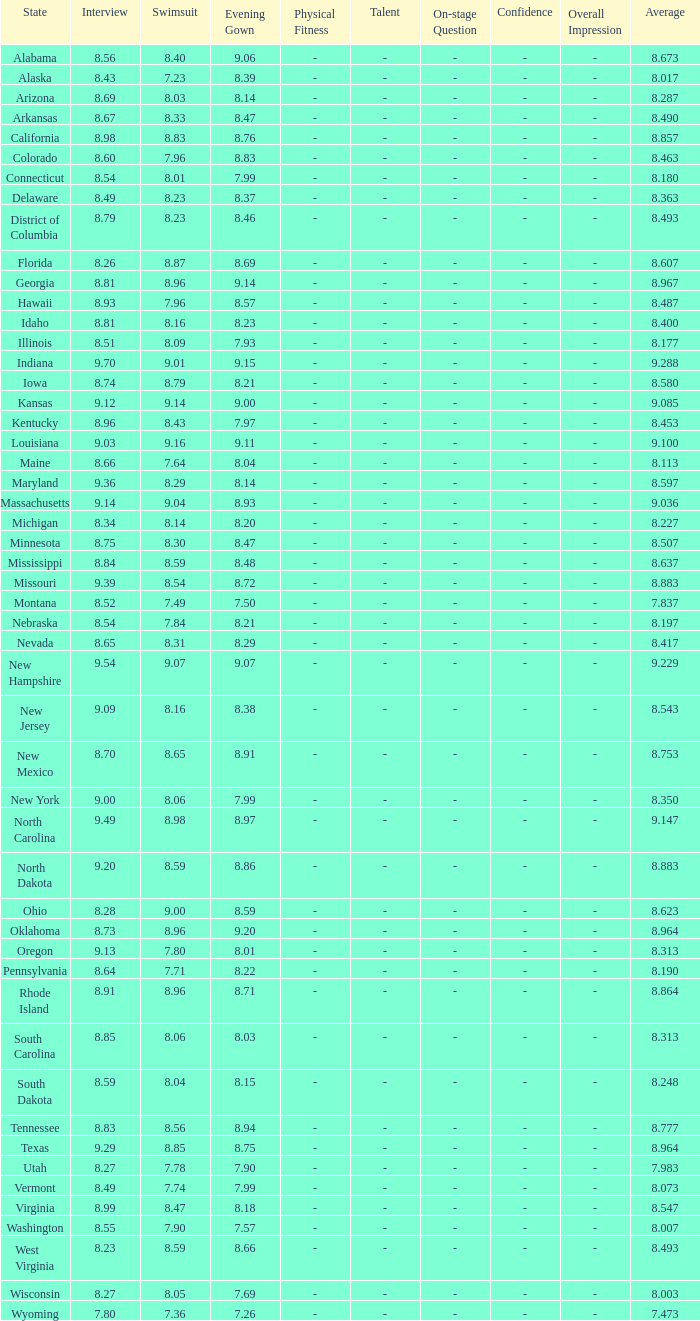Name the total number of swimsuits for evening gowns less than 8.21 and average of 8.453 with interview less than 9.09 1.0. 